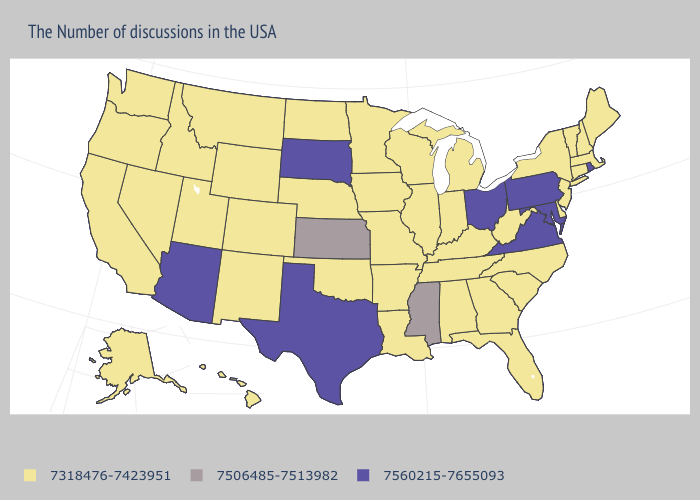What is the value of New Hampshire?
Short answer required. 7318476-7423951. Does New Hampshire have a lower value than California?
Answer briefly. No. Does Michigan have the lowest value in the MidWest?
Answer briefly. Yes. What is the value of West Virginia?
Be succinct. 7318476-7423951. Does Iowa have the lowest value in the MidWest?
Be succinct. Yes. Which states have the highest value in the USA?
Write a very short answer. Rhode Island, Maryland, Pennsylvania, Virginia, Ohio, Texas, South Dakota, Arizona. What is the highest value in states that border New Jersey?
Write a very short answer. 7560215-7655093. What is the lowest value in the USA?
Give a very brief answer. 7318476-7423951. What is the value of Vermont?
Give a very brief answer. 7318476-7423951. Which states have the lowest value in the USA?
Be succinct. Maine, Massachusetts, New Hampshire, Vermont, Connecticut, New York, New Jersey, Delaware, North Carolina, South Carolina, West Virginia, Florida, Georgia, Michigan, Kentucky, Indiana, Alabama, Tennessee, Wisconsin, Illinois, Louisiana, Missouri, Arkansas, Minnesota, Iowa, Nebraska, Oklahoma, North Dakota, Wyoming, Colorado, New Mexico, Utah, Montana, Idaho, Nevada, California, Washington, Oregon, Alaska, Hawaii. Which states have the lowest value in the USA?
Short answer required. Maine, Massachusetts, New Hampshire, Vermont, Connecticut, New York, New Jersey, Delaware, North Carolina, South Carolina, West Virginia, Florida, Georgia, Michigan, Kentucky, Indiana, Alabama, Tennessee, Wisconsin, Illinois, Louisiana, Missouri, Arkansas, Minnesota, Iowa, Nebraska, Oklahoma, North Dakota, Wyoming, Colorado, New Mexico, Utah, Montana, Idaho, Nevada, California, Washington, Oregon, Alaska, Hawaii. Does Nebraska have a lower value than Vermont?
Write a very short answer. No. Does South Carolina have the highest value in the USA?
Concise answer only. No. What is the highest value in states that border South Carolina?
Short answer required. 7318476-7423951. 